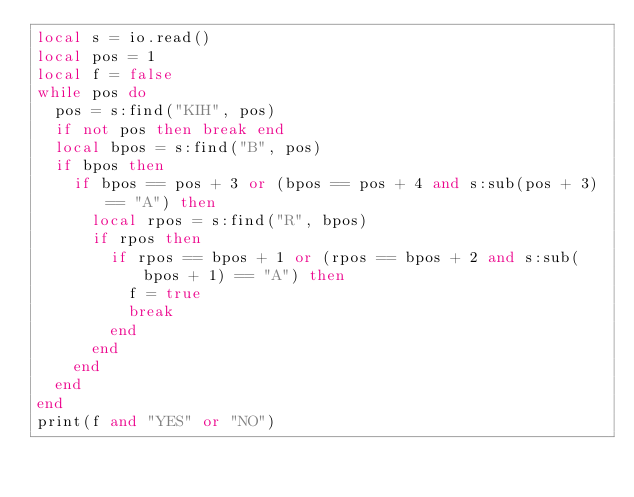<code> <loc_0><loc_0><loc_500><loc_500><_Lua_>local s = io.read()
local pos = 1
local f = false
while pos do
  pos = s:find("KIH", pos)
  if not pos then break end
  local bpos = s:find("B", pos)
  if bpos then
    if bpos == pos + 3 or (bpos == pos + 4 and s:sub(pos + 3) == "A") then
      local rpos = s:find("R", bpos)
      if rpos then
        if rpos == bpos + 1 or (rpos == bpos + 2 and s:sub(bpos + 1) == "A") then
          f = true
          break
        end
      end
    end
  end
end
print(f and "YES" or "NO")
</code> 